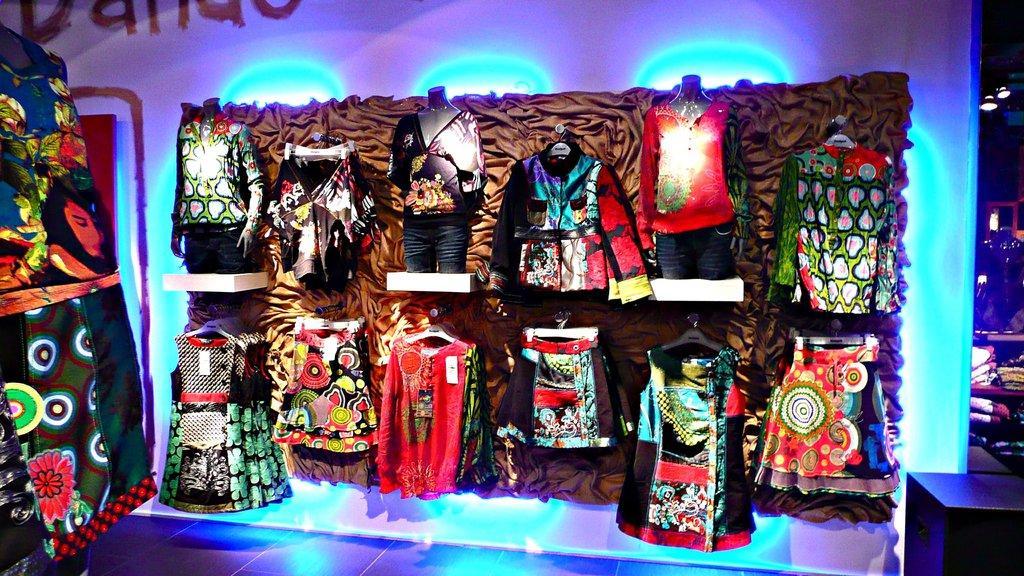Please provide a concise description of this image. In this image I can see the floor, few lights, few mannequins, few clothes to the mannequins and few cloths hanged to the hangers. In the background I can see few lights to the ceiling. 